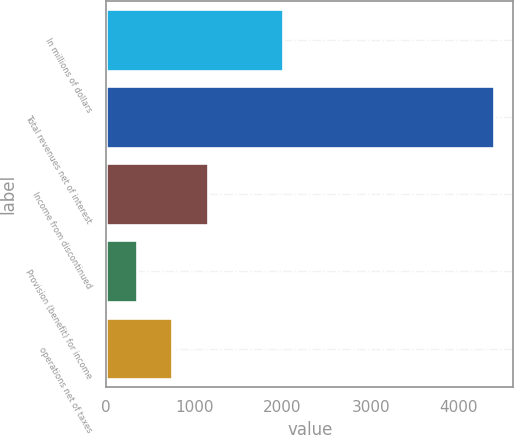<chart> <loc_0><loc_0><loc_500><loc_500><bar_chart><fcel>In millions of dollars<fcel>Total revenues net of interest<fcel>Income from discontinued<fcel>Provision (benefit) for income<fcel>operations net of taxes<nl><fcel>2007<fcel>4398<fcel>1155.6<fcel>345<fcel>750.3<nl></chart> 